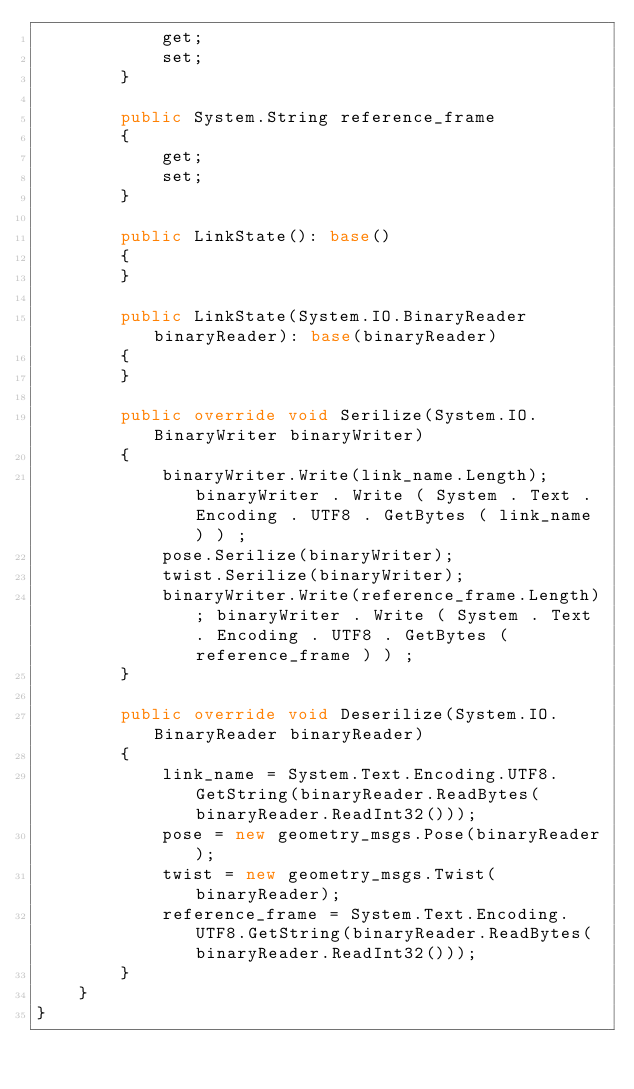Convert code to text. <code><loc_0><loc_0><loc_500><loc_500><_C#_>            get;
            set;
        }

        public System.String reference_frame
        {
            get;
            set;
        }

        public LinkState(): base()
        {
        }

        public LinkState(System.IO.BinaryReader binaryReader): base(binaryReader)
        {
        }

        public override void Serilize(System.IO.BinaryWriter binaryWriter)
        {
            binaryWriter.Write(link_name.Length); binaryWriter . Write ( System . Text . Encoding . UTF8 . GetBytes ( link_name ) ) ; 
            pose.Serilize(binaryWriter);
            twist.Serilize(binaryWriter);
            binaryWriter.Write(reference_frame.Length); binaryWriter . Write ( System . Text . Encoding . UTF8 . GetBytes ( reference_frame ) ) ; 
        }

        public override void Deserilize(System.IO.BinaryReader binaryReader)
        {
            link_name = System.Text.Encoding.UTF8.GetString(binaryReader.ReadBytes(binaryReader.ReadInt32()));
            pose = new geometry_msgs.Pose(binaryReader);
            twist = new geometry_msgs.Twist(binaryReader);
            reference_frame = System.Text.Encoding.UTF8.GetString(binaryReader.ReadBytes(binaryReader.ReadInt32()));
        }
    }
}</code> 